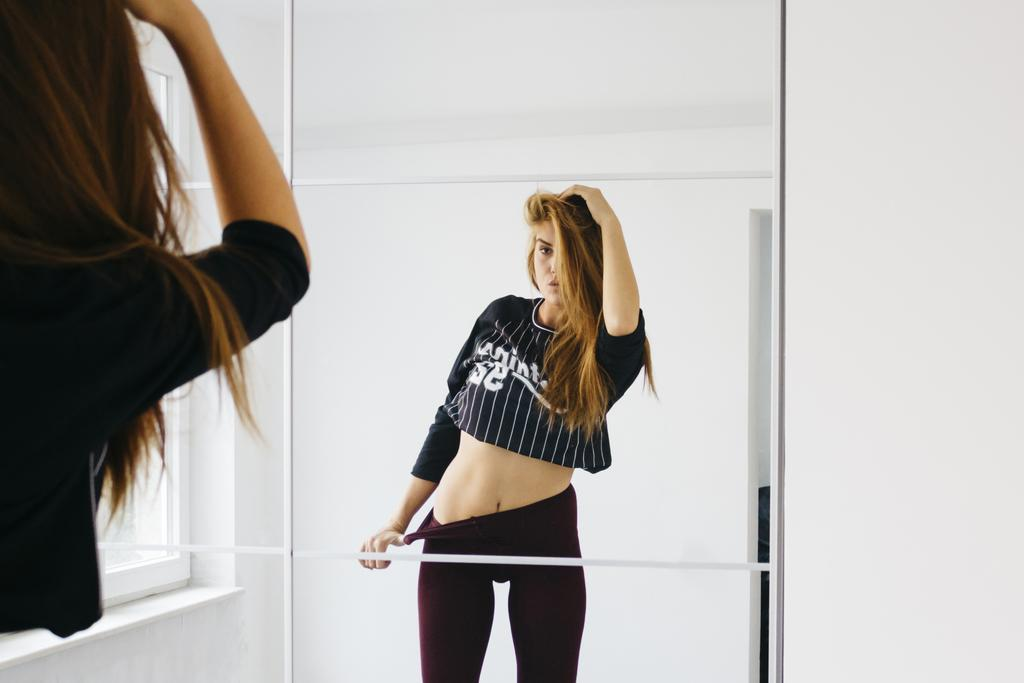Who is present in the image? There is a lady in the image. What is the lady doing in the image? The lady is in front of a mirror. What can be seen in the mirror? The reflection of the lady is visible in the mirror. What is visible in the background of the image? There is a window and a wall in the image. What type of teeth can be seen in the image? There are no teeth visible in the image; it features a lady in front of a mirror. 